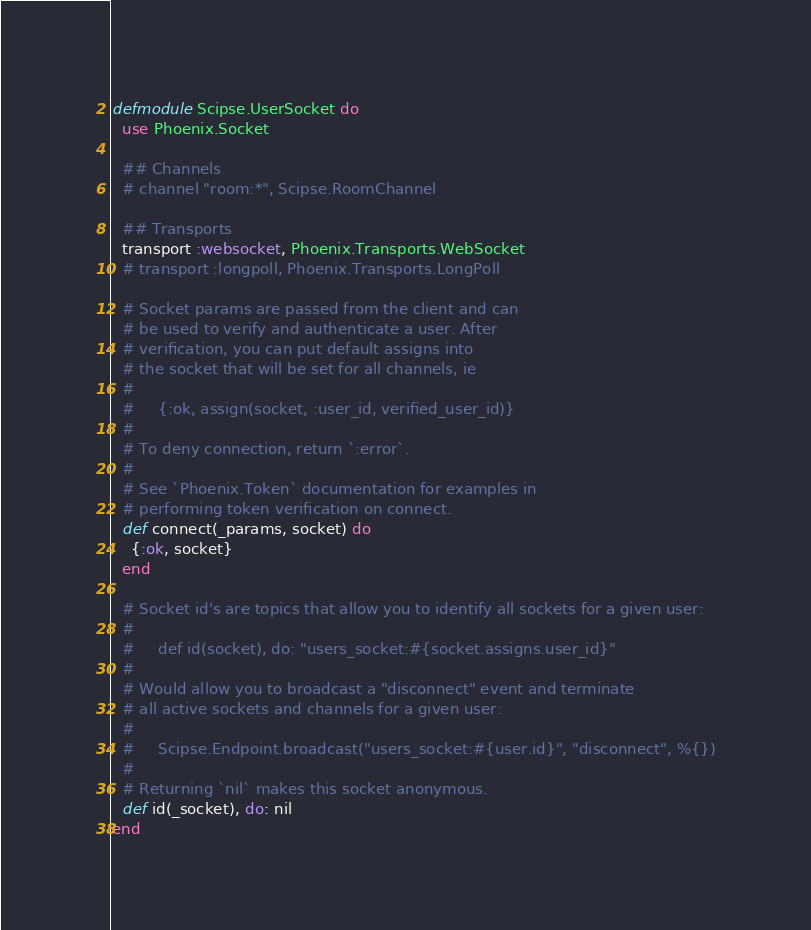Convert code to text. <code><loc_0><loc_0><loc_500><loc_500><_Elixir_>defmodule Scipse.UserSocket do
  use Phoenix.Socket

  ## Channels
  # channel "room:*", Scipse.RoomChannel

  ## Transports
  transport :websocket, Phoenix.Transports.WebSocket
  # transport :longpoll, Phoenix.Transports.LongPoll

  # Socket params are passed from the client and can
  # be used to verify and authenticate a user. After
  # verification, you can put default assigns into
  # the socket that will be set for all channels, ie
  #
  #     {:ok, assign(socket, :user_id, verified_user_id)}
  #
  # To deny connection, return `:error`.
  #
  # See `Phoenix.Token` documentation for examples in
  # performing token verification on connect.
  def connect(_params, socket) do
    {:ok, socket}
  end

  # Socket id's are topics that allow you to identify all sockets for a given user:
  #
  #     def id(socket), do: "users_socket:#{socket.assigns.user_id}"
  #
  # Would allow you to broadcast a "disconnect" event and terminate
  # all active sockets and channels for a given user:
  #
  #     Scipse.Endpoint.broadcast("users_socket:#{user.id}", "disconnect", %{})
  #
  # Returning `nil` makes this socket anonymous.
  def id(_socket), do: nil
end
</code> 